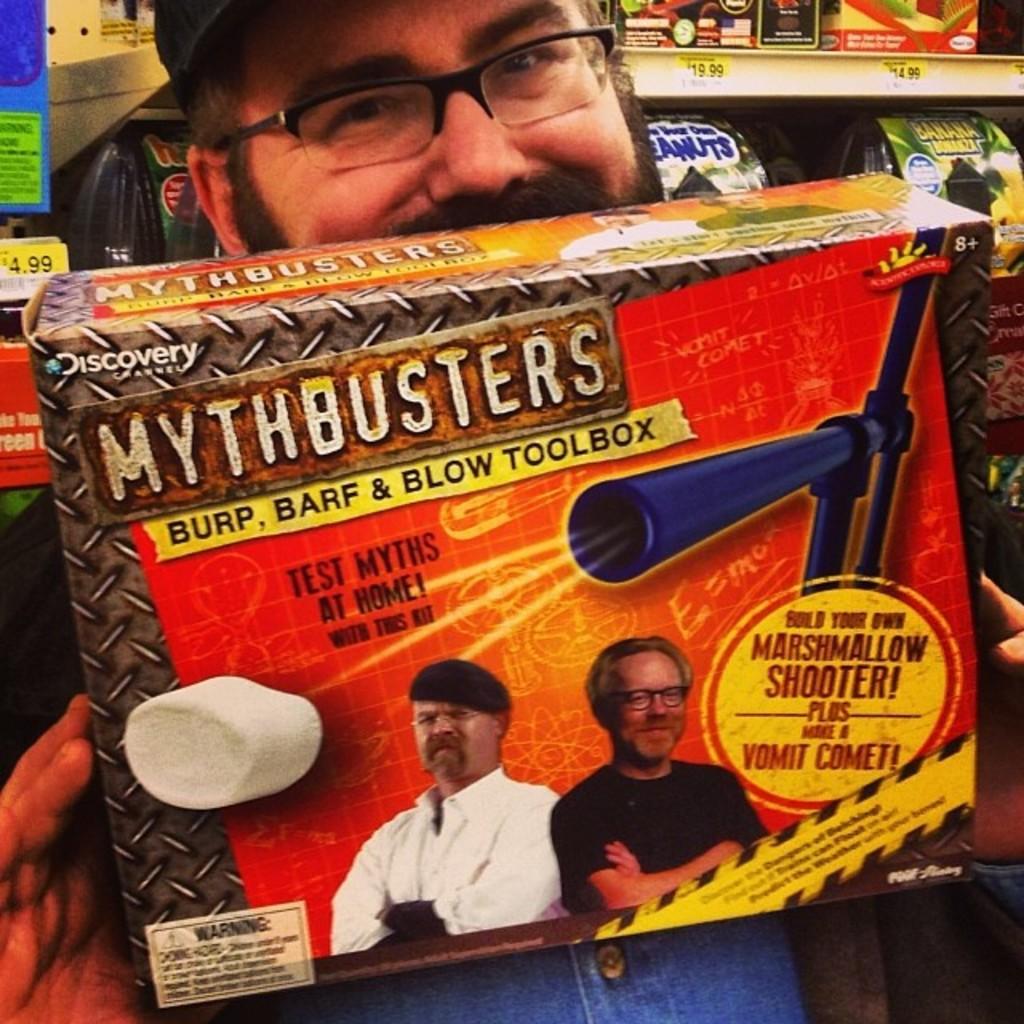Describe this image in one or two sentences. In this image we can see a person wearing spectacles and a cap is holding a box in his hand. In the background, we can see group of items placed in the rack. 